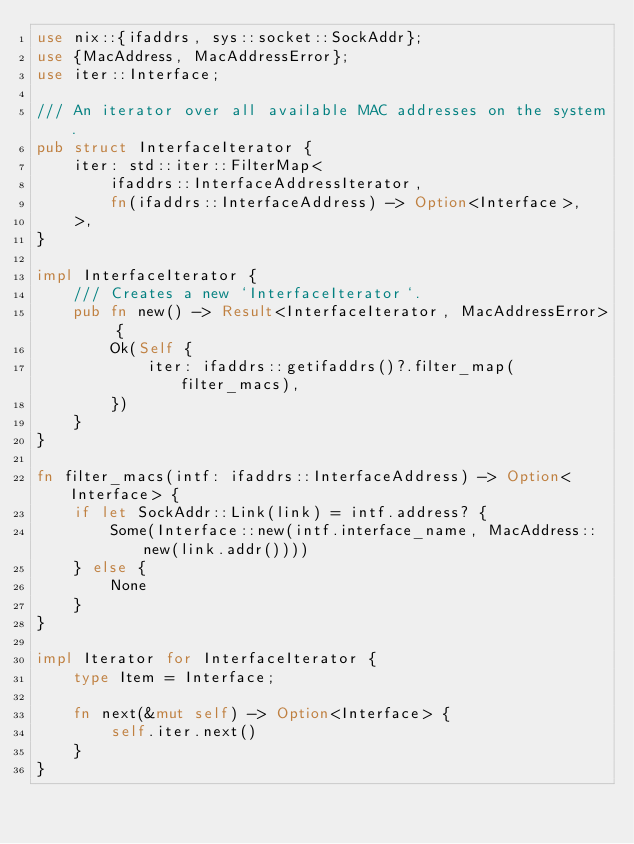<code> <loc_0><loc_0><loc_500><loc_500><_Rust_>use nix::{ifaddrs, sys::socket::SockAddr};
use {MacAddress, MacAddressError};
use iter::Interface;

/// An iterator over all available MAC addresses on the system.
pub struct InterfaceIterator {
    iter: std::iter::FilterMap<
        ifaddrs::InterfaceAddressIterator,
        fn(ifaddrs::InterfaceAddress) -> Option<Interface>,
    >,
}

impl InterfaceIterator {
    /// Creates a new `InterfaceIterator`.
    pub fn new() -> Result<InterfaceIterator, MacAddressError> {
        Ok(Self {
            iter: ifaddrs::getifaddrs()?.filter_map(filter_macs),
        })
    }
}

fn filter_macs(intf: ifaddrs::InterfaceAddress) -> Option<Interface> {
    if let SockAddr::Link(link) = intf.address? {
        Some(Interface::new(intf.interface_name, MacAddress::new(link.addr())))
    } else {
        None
    }
}

impl Iterator for InterfaceIterator {
    type Item = Interface;

    fn next(&mut self) -> Option<Interface> {
        self.iter.next()
    }
}
</code> 